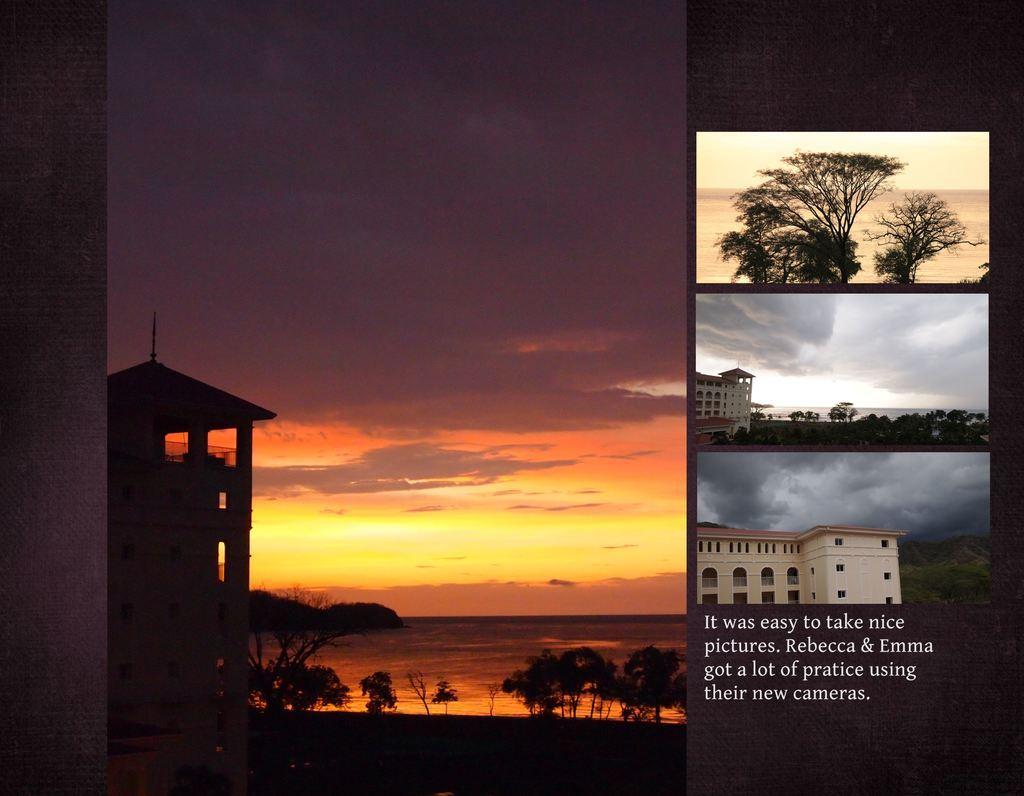In one or two sentences, can you explain what this image depicts? In this image we can see the collage picture. And there are buildings, trees and the sky. And we can see the text written on the poster. 